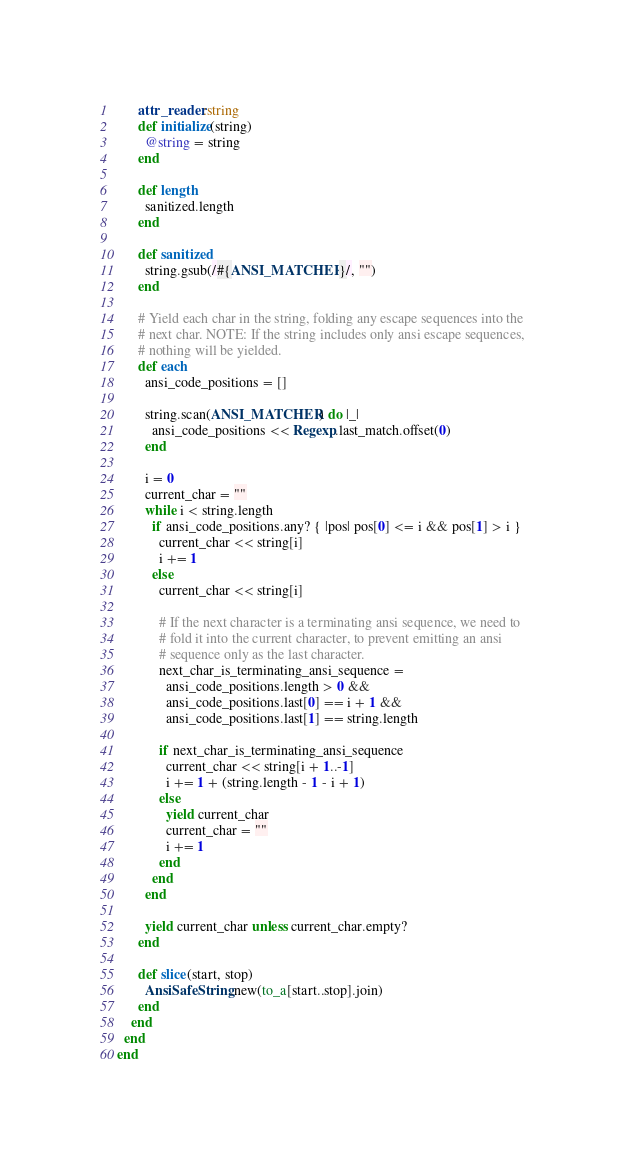Convert code to text. <code><loc_0><loc_0><loc_500><loc_500><_Ruby_>      attr_reader :string
      def initialize(string)
        @string = string
      end

      def length
        sanitized.length
      end

      def sanitized
        string.gsub(/#{ANSI_MATCHER}/, "")
      end

      # Yield each char in the string, folding any escape sequences into the
      # next char. NOTE: If the string includes only ansi escape sequences,
      # nothing will be yielded.
      def each
        ansi_code_positions = []

        string.scan(ANSI_MATCHER) do |_|
          ansi_code_positions << Regexp.last_match.offset(0)
        end

        i = 0
        current_char = ""
        while i < string.length
          if ansi_code_positions.any? { |pos| pos[0] <= i && pos[1] > i }
            current_char << string[i]
            i += 1
          else
            current_char << string[i]

            # If the next character is a terminating ansi sequence, we need to
            # fold it into the current character, to prevent emitting an ansi
            # sequence only as the last character.
            next_char_is_terminating_ansi_sequence =
              ansi_code_positions.length > 0 &&
              ansi_code_positions.last[0] == i + 1 &&
              ansi_code_positions.last[1] == string.length

            if next_char_is_terminating_ansi_sequence
              current_char << string[i + 1..-1]
              i += 1 + (string.length - 1 - i + 1)
            else
              yield current_char
              current_char = ""
              i += 1
            end
          end
        end

        yield current_char unless current_char.empty?
      end

      def slice(start, stop)
        AnsiSafeString.new(to_a[start..stop].join)
      end
    end
  end
end
</code> 